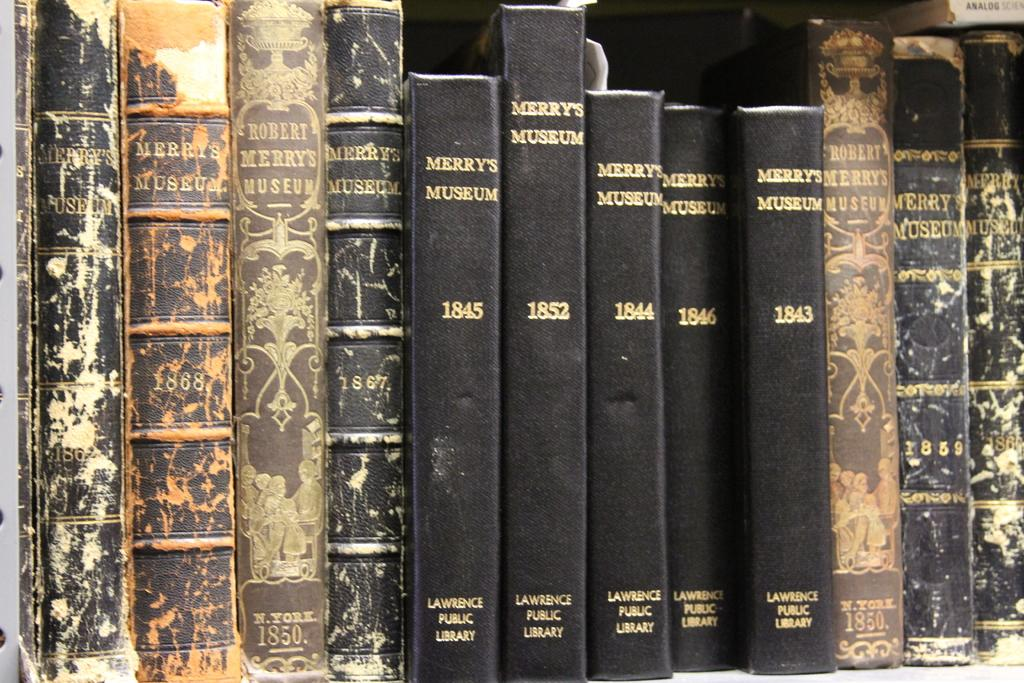<image>
Offer a succinct explanation of the picture presented. A bunch of old looking books, most of which are titled Merry's Museum. 